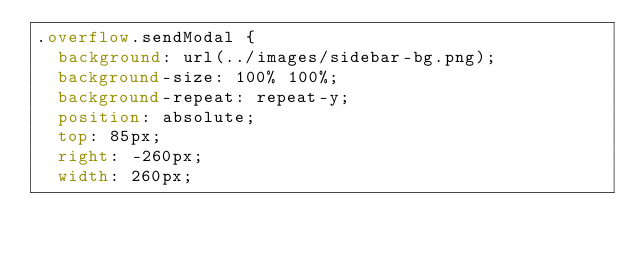Convert code to text. <code><loc_0><loc_0><loc_500><loc_500><_CSS_>.overflow.sendModal {
  background: url(../images/sidebar-bg.png);
  background-size: 100% 100%;
  background-repeat: repeat-y;
  position: absolute;
  top: 85px;
  right: -260px;
  width: 260px;</code> 